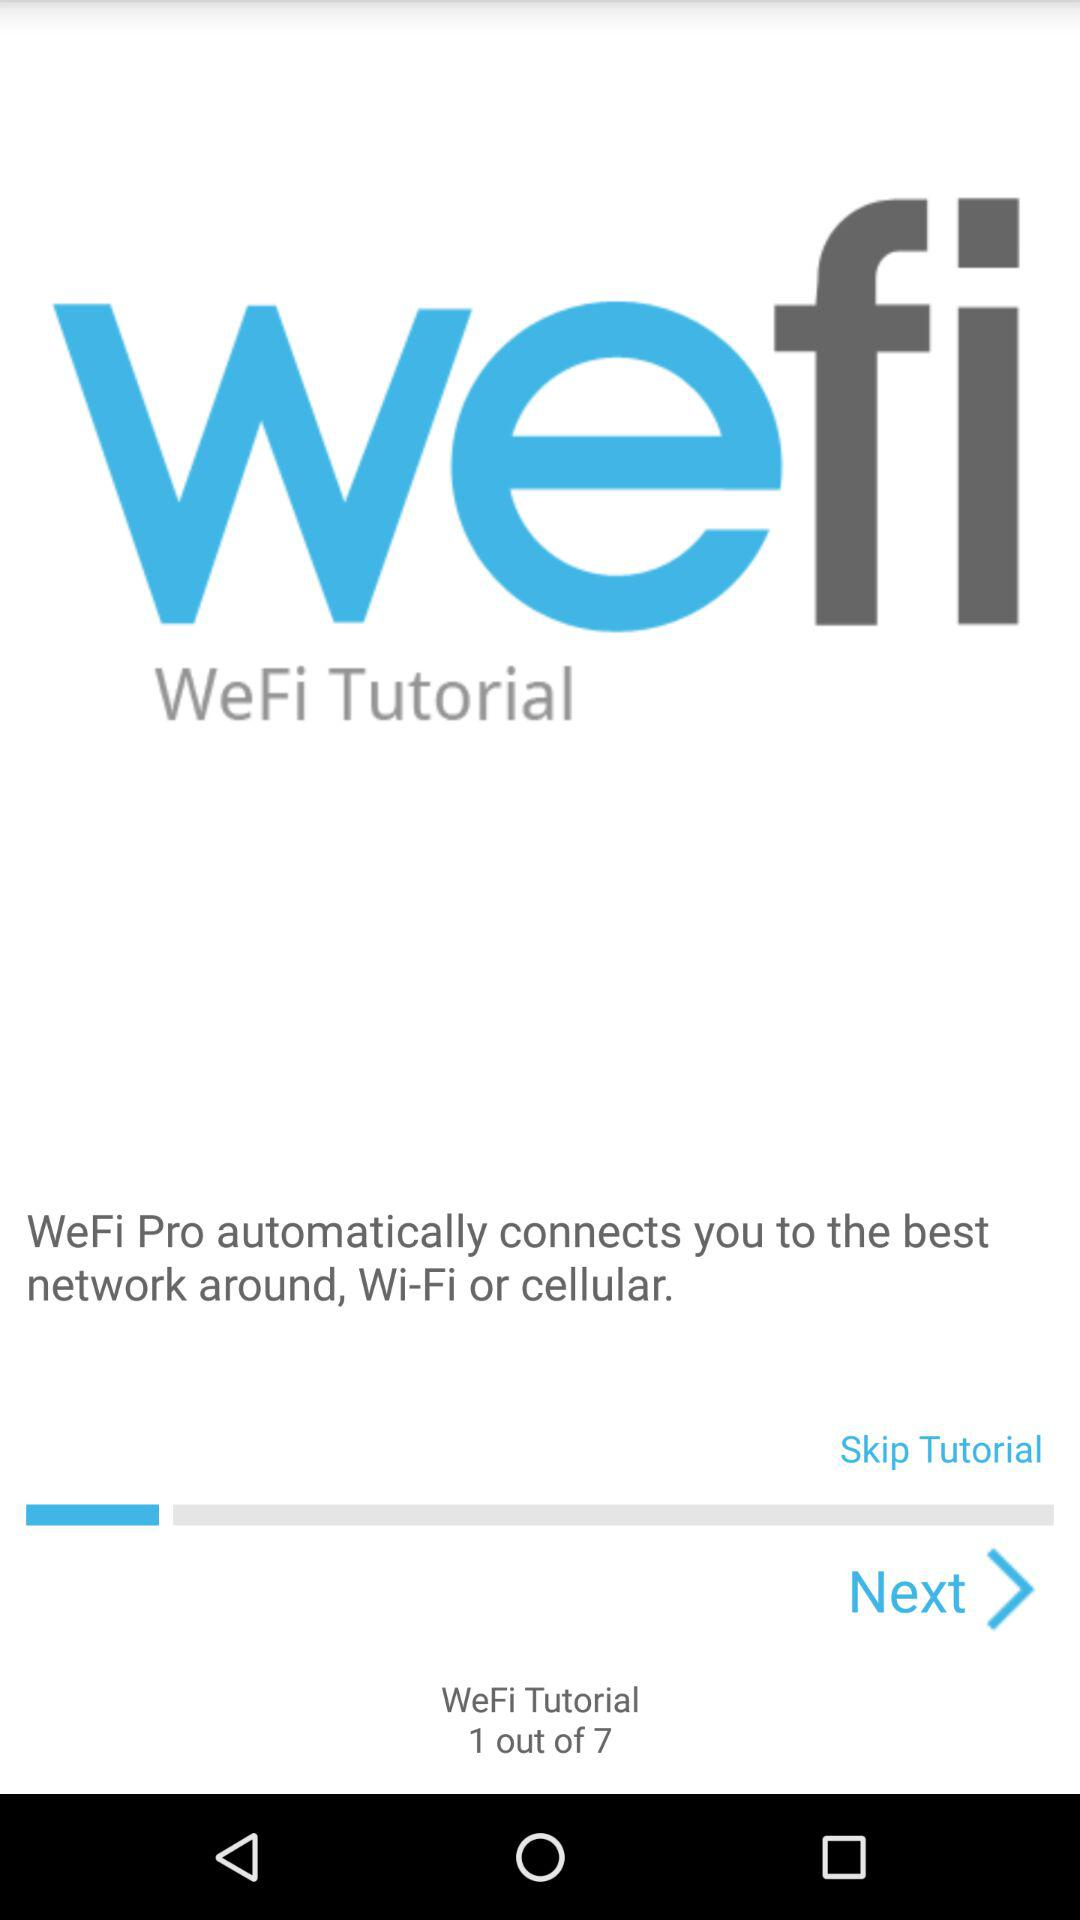How many total pages are there in the tutorial? There are 7 total pages. 